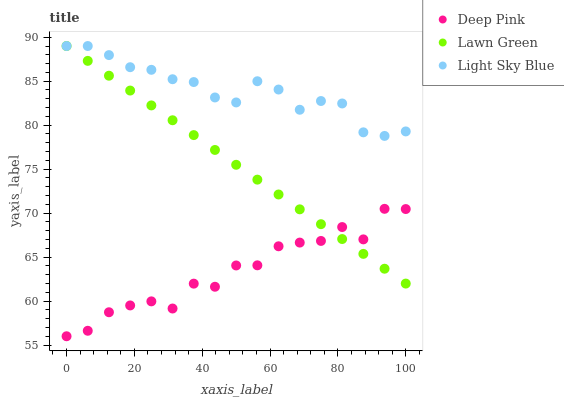Does Deep Pink have the minimum area under the curve?
Answer yes or no. Yes. Does Light Sky Blue have the maximum area under the curve?
Answer yes or no. Yes. Does Light Sky Blue have the minimum area under the curve?
Answer yes or no. No. Does Deep Pink have the maximum area under the curve?
Answer yes or no. No. Is Lawn Green the smoothest?
Answer yes or no. Yes. Is Deep Pink the roughest?
Answer yes or no. Yes. Is Light Sky Blue the smoothest?
Answer yes or no. No. Is Light Sky Blue the roughest?
Answer yes or no. No. Does Deep Pink have the lowest value?
Answer yes or no. Yes. Does Light Sky Blue have the lowest value?
Answer yes or no. No. Does Light Sky Blue have the highest value?
Answer yes or no. Yes. Does Deep Pink have the highest value?
Answer yes or no. No. Is Deep Pink less than Light Sky Blue?
Answer yes or no. Yes. Is Light Sky Blue greater than Deep Pink?
Answer yes or no. Yes. Does Lawn Green intersect Light Sky Blue?
Answer yes or no. Yes. Is Lawn Green less than Light Sky Blue?
Answer yes or no. No. Is Lawn Green greater than Light Sky Blue?
Answer yes or no. No. Does Deep Pink intersect Light Sky Blue?
Answer yes or no. No. 